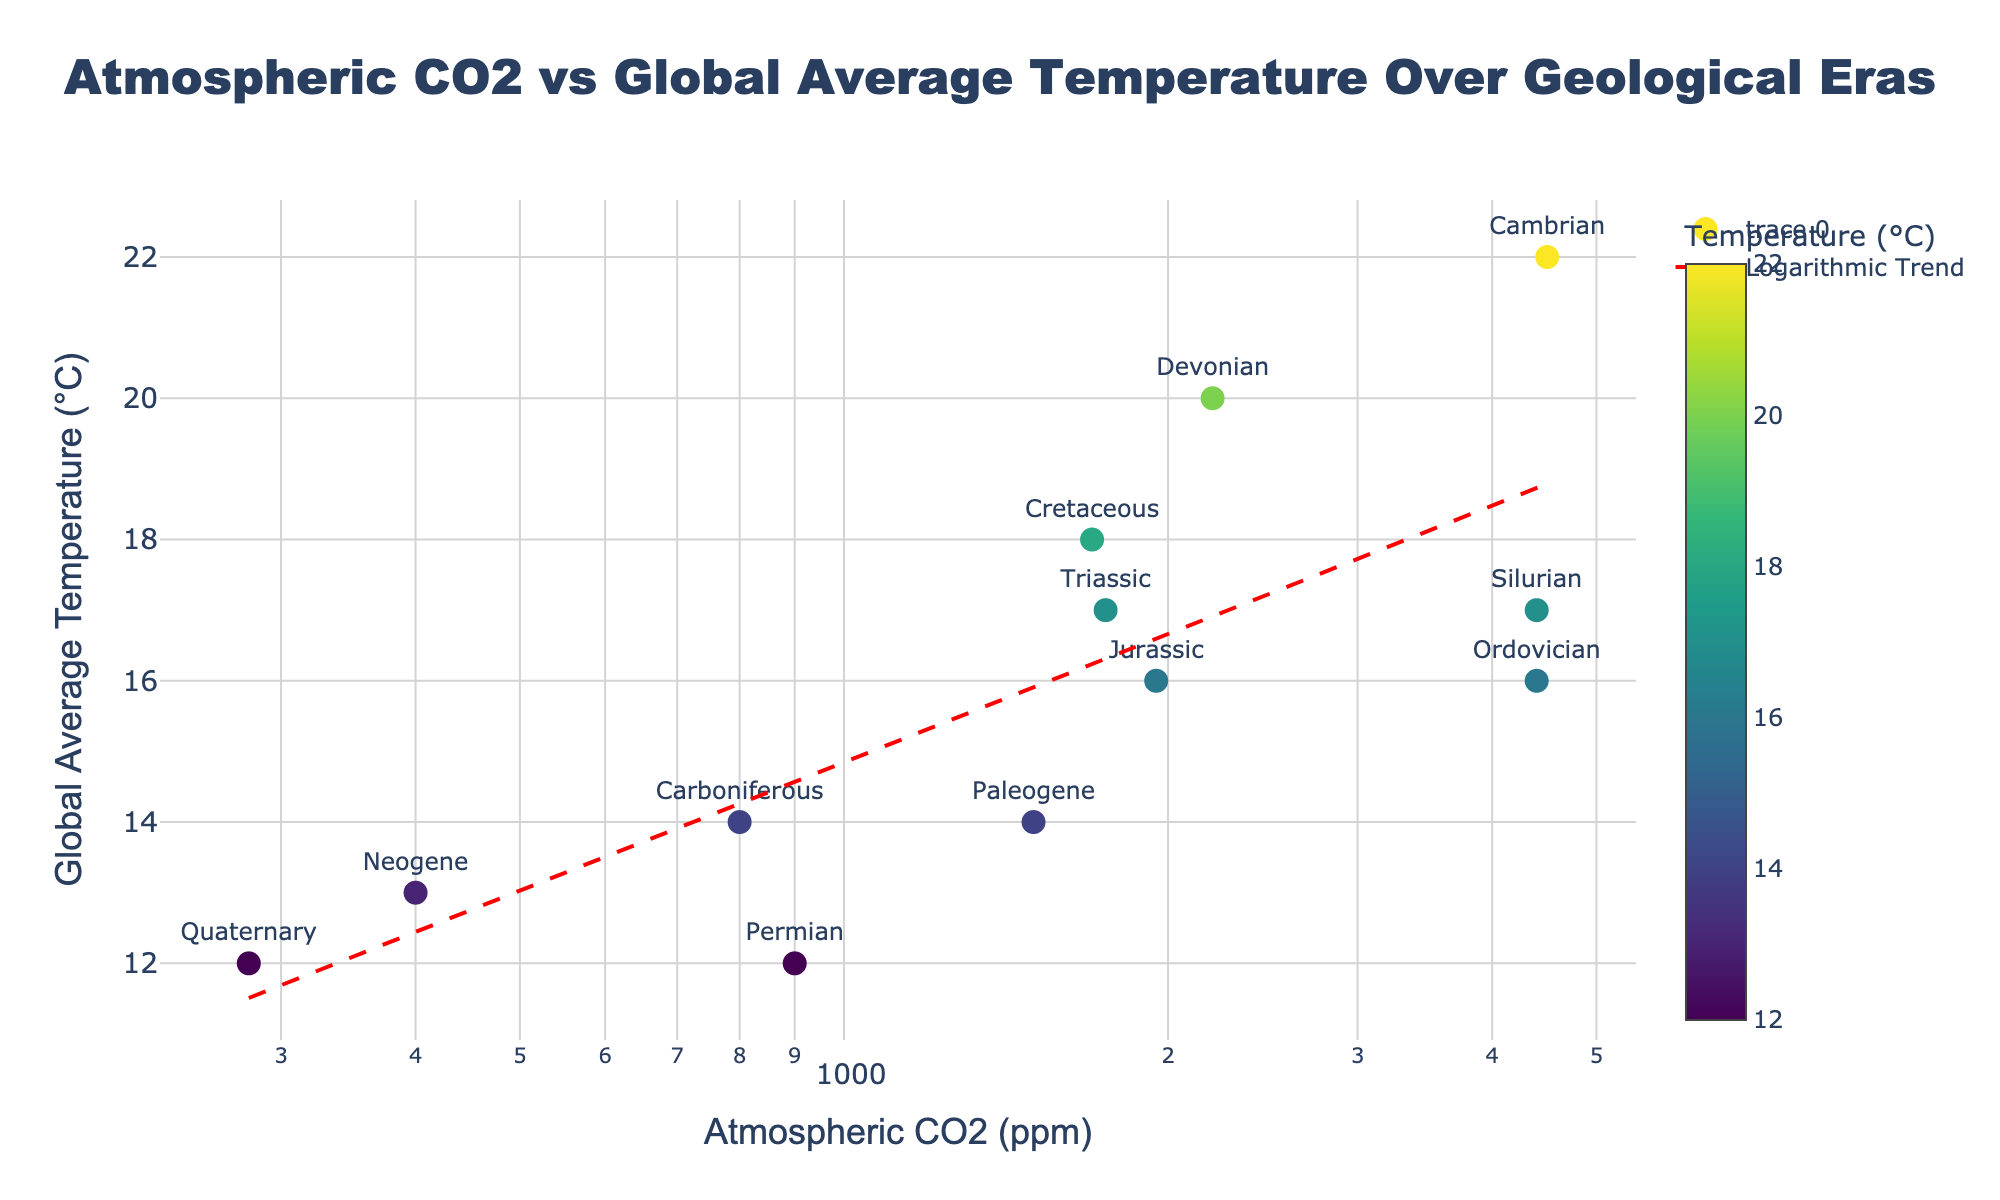what is the title of the figure? The title is usually displayed at the top of the figure. In this case, it is "Atmospheric CO2 vs Global Average Temperature Over Geological Eras".
Answer: Atmospheric CO2 vs Global Average Temperature Over Geological Eras How many data points are shown on this scatter plot? Each era represents a data point on the scatter plot. Counting the eras listed (Cambrian, Ordovician, Silurian, etc.), there are 12 data points.
Answer: 12 Which era has the highest atmospheric CO2 level? By examining the x-axis and labels near the data points, the Cambrian era has the highest atmospheric CO2 level at 4500 ppm.
Answer: Cambrian What's the relationship between atmospheric CO2 levels and global average temperature based on the trendline? The trendline shows a positive correlation; as atmospheric CO2 levels increase, the global average temperature also tends to rise. This is evident from the upward slope of the trendline.
Answer: Positive correlation Which era corresponds to the point with the lowest global average temperature? By checking the y-axis and labels, the Quaternary era has the lowest global average temperature at 12°C.
Answer: Quaternary What is the global average temperature in the Cambrian era? The scatter plot's hover information reveals that the global average temperature for the Cambrian era is 22°C.
Answer: 22°C Compare the atmospheric CO2 levels between the Triassic and the Carboniferous eras. Which one is higher and by how much? The Triassic era has an atmospheric CO2 level of 1750 ppm and the Carboniferous era has 800 ppm. The difference is 1750 - 800 = 950 ppm.
Answer: Triassic is higher by 950 ppm What is the logarithmic trendline equation depicted in the scatter plot? The y = m*log10(x) + b form is used, where m and b are coefficients determined through a logarithmic fit of the data. Here, it is approximate to y = 1.8371*log10(x) + 14.109.
Answer: y = 1.84*log10(x) + 14.11 How does the average temperature in the Silurian era compare to that in the Paleogene era? The Silurian era has an average temperature of 17°C, while the Paleogene era has 14°C. Thus, the Silurian era is 3°C warmer.
Answer: Silurian era is 3°C warmer Which eras have atmospheric CO2 levels closest to the logarithmic average of this dataset? To find the geographical mean, one must consider the logarithmic scale values. Eras like Devonian (2200 ppm) and Triassic (1750 ppm) are closer to the mid-range of CO2 levels after this calculation.
Answer: Devonian and Triassic 